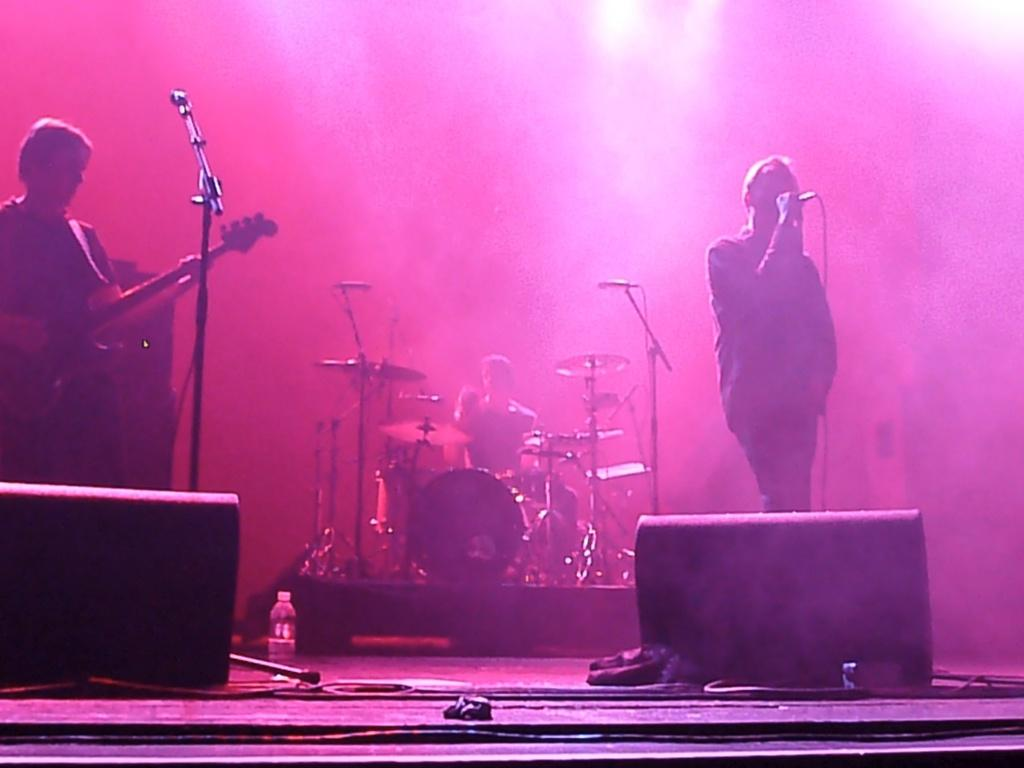How many people are present in the image? There are three people in the image. Where are two of the people located? Two of the people are standing on a stage. What objects can be seen in the image related to music? There is a guitar, microphones, and drums in the image. Can you describe any other objects in the image? There is a bottle and some unspecified objects in the image. What can be said about the background of the image? The background of the image is blurry. What type of sticks can be seen in the image? There are no sticks present in the image. Is the image taking place during the night or during the day? The time of day cannot be determined from the image. Where is the lunchroom located in the image? There is no lunchroom present in the image. 